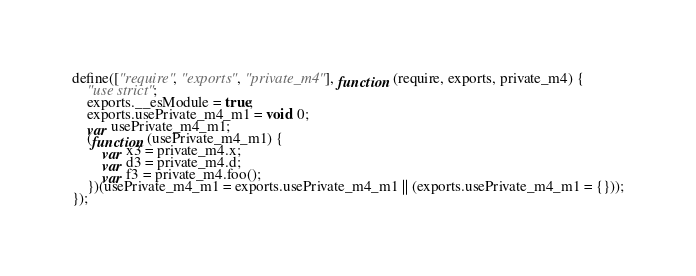Convert code to text. <code><loc_0><loc_0><loc_500><loc_500><_JavaScript_>define(["require", "exports", "private_m4"], function (require, exports, private_m4) {
    "use strict";
    exports.__esModule = true;
    exports.usePrivate_m4_m1 = void 0;
    var usePrivate_m4_m1;
    (function (usePrivate_m4_m1) {
        var x3 = private_m4.x;
        var d3 = private_m4.d;
        var f3 = private_m4.foo();
    })(usePrivate_m4_m1 = exports.usePrivate_m4_m1 || (exports.usePrivate_m4_m1 = {}));
});
</code> 